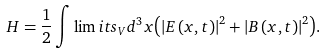Convert formula to latex. <formula><loc_0><loc_0><loc_500><loc_500>H = \frac { 1 } { 2 } \int \lim i t s _ { V } d ^ { 3 } x { \left ( { \left | { { E } \left ( { { x } , t } \right ) } \right | ^ { 2 } + \left | { { B } \left ( { { x } , t } \right ) } \right | ^ { 2 } } \right ) } .</formula> 